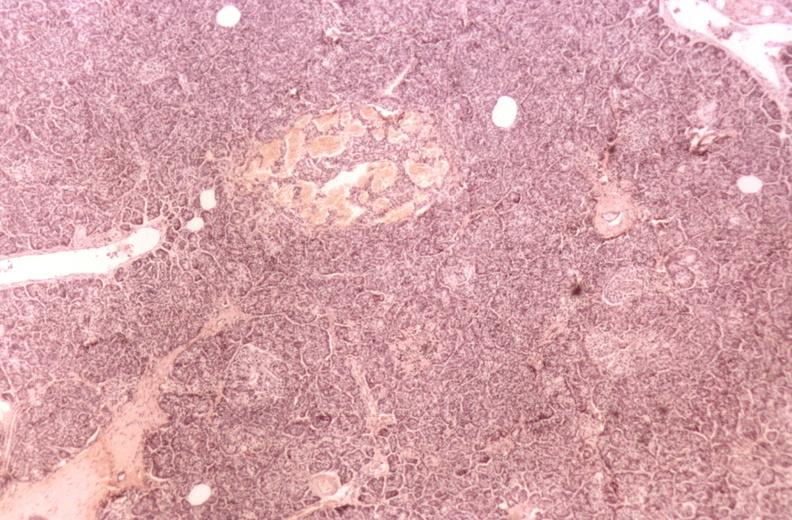s additional micros present?
Answer the question using a single word or phrase. No 